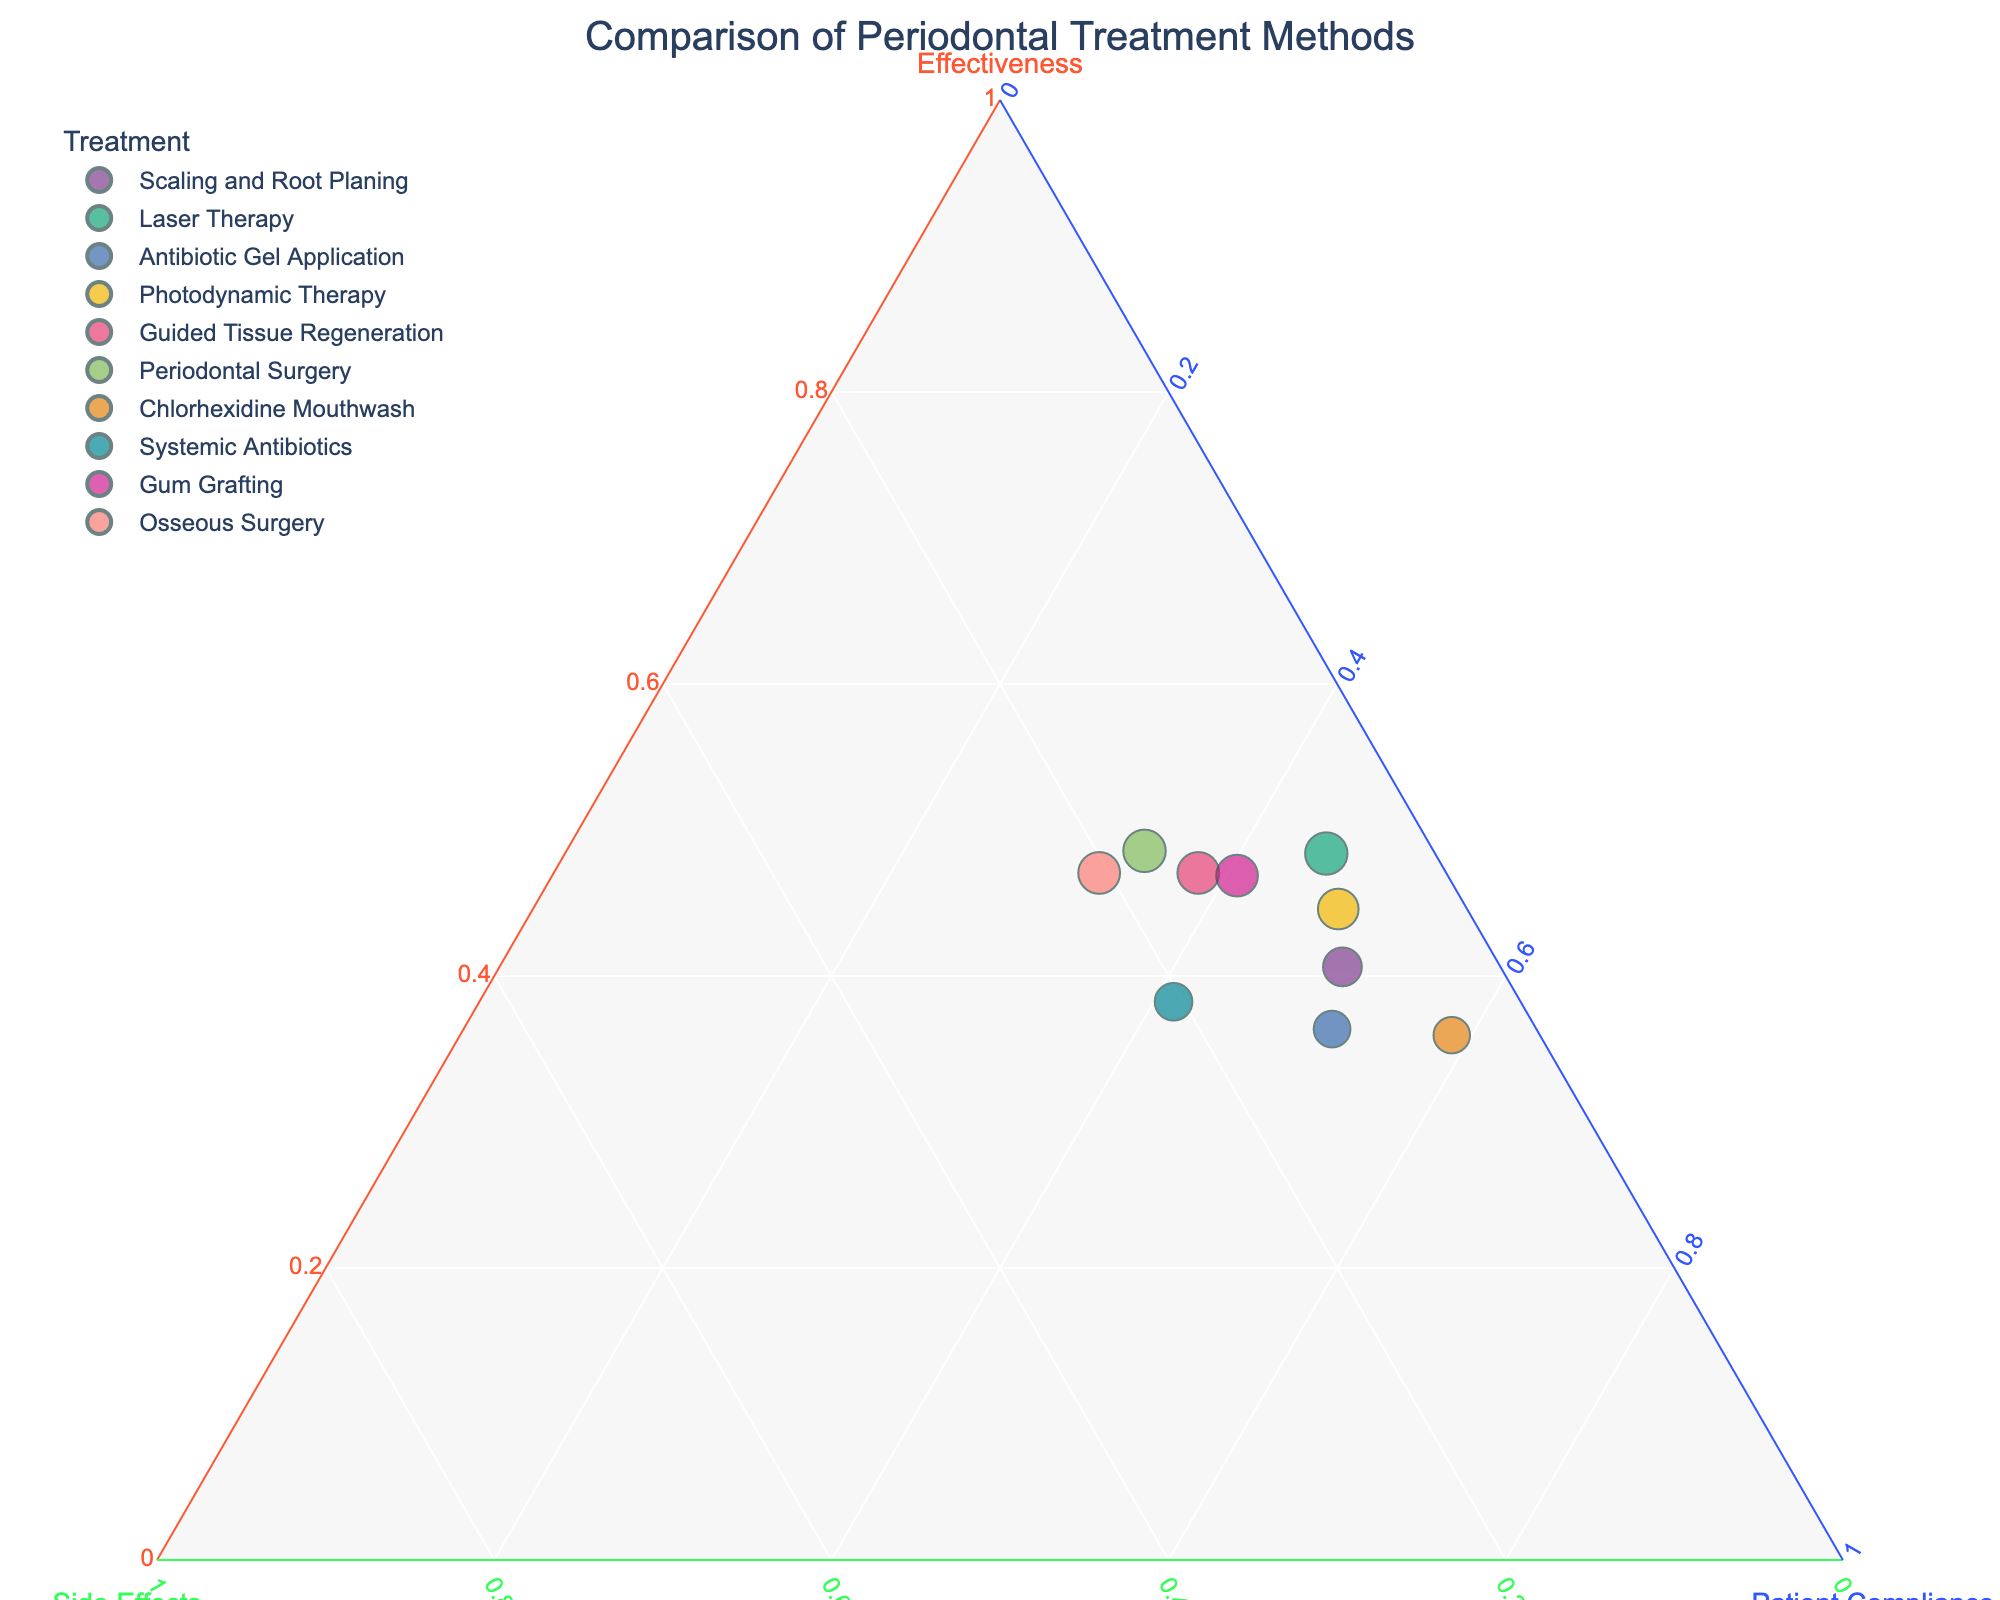What's the title of the figure? The title is clearly visible at the top of the figure. It reads "Comparison of Periodontal Treatment Methods".
Answer: Comparison of Periodontal Treatment Methods How many different periodontal treatment methods are shown in the plot? By counting the markers on the plot or by listing the treatments in the legend, we can see that there are 10 different periodontal treatment methods displayed.
Answer: 10 Which treatment method has the highest effectiveness? The effectiveness is represented by the size of the markers and their position on the ternary plot. By looking at the plot, we see that "Periodontal Surgery" has the largest marker, indicating the highest effectiveness.
Answer: Periodontal Surgery Which treatment method has the lowest side effects? Side effects are represented along the b-axis. The treatment closest to the bottom left of the triangle will have the lowest side effects. According to the plot, "Chlorhexidine Mouthwash" has the lowest side effects.
Answer: Chlorhexidine Mouthwash What is the relative position of "Laser Therapy" compared to "Osseous Surgery" in terms of patient compliance? Patient compliance is represented along the c-axis. "Laser Therapy" is positioned higher than "Osseous Surgery" along this axis, indicating higher patient compliance.
Answer: Laser Therapy has higher patient compliance How does "Gum Grafting" compare to "Antibiotic Gel Application" in terms of effectiveness and side effects? In terms of effectiveness, "Gum Grafting" is represented by a larger marker than "Antibiotic Gel Application", indicating higher effectiveness. For side effects, we look at their positions along the b-axis. "Gum Grafting" is closer to the side effects axis, implying higher side effects compared to "Antibiotic Gel Application".
Answer: Gum Grafting has higher effectiveness and higher side effects Which treatment method is closest to achieving a balance between effectiveness, patient compliance, and side effects? A balanced treatment method would be positioned more centrally in the ternary plot, equidistant from all three axes. "Photodynamic Therapy" appears to be the most centrally located, suggesting a balance between effectiveness, patient compliance, and side effects.
Answer: Photodynamic Therapy Which treatment has the best combination of high effectiveness and low side effects? For high effectiveness and low side effects, we look for treatments that are high on the effectiveness axis (large markers) and low on the side effects axis (closer to the bottom-left corner). "Laser Therapy" stands out as it has a high effectiveness and low side effects.
Answer: Laser Therapy 